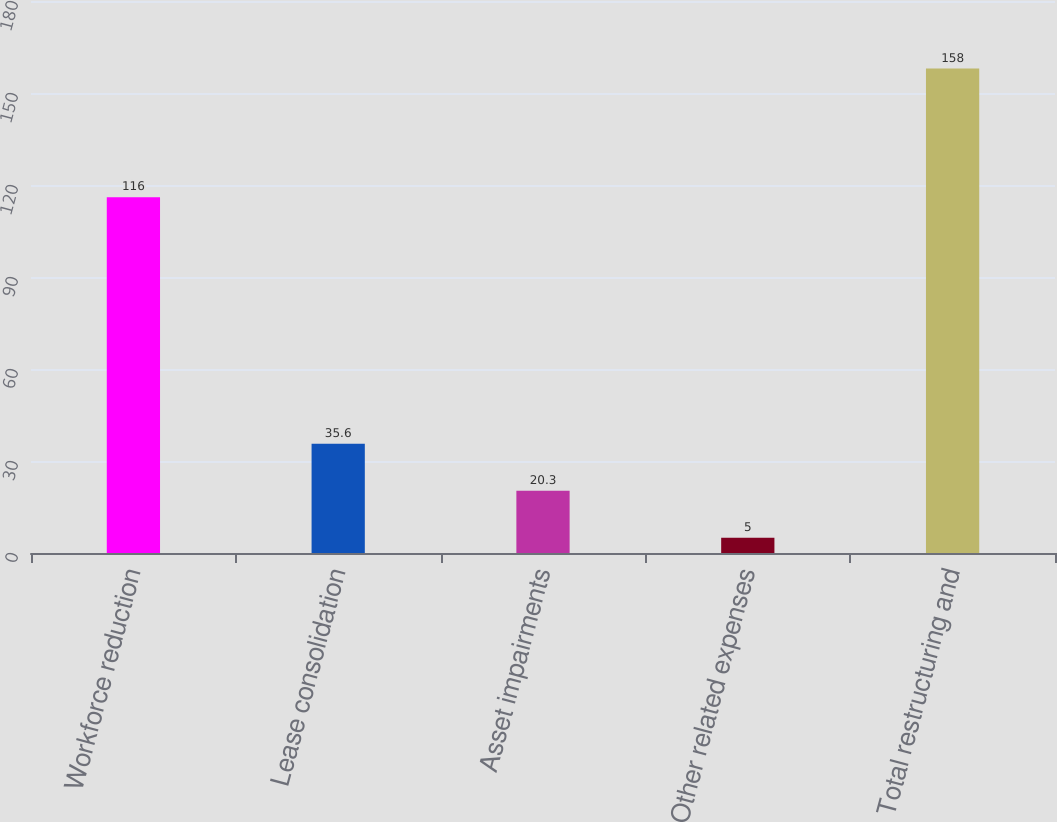Convert chart to OTSL. <chart><loc_0><loc_0><loc_500><loc_500><bar_chart><fcel>Workforce reduction<fcel>Lease consolidation<fcel>Asset impairments<fcel>Other related expenses<fcel>Total restructuring and<nl><fcel>116<fcel>35.6<fcel>20.3<fcel>5<fcel>158<nl></chart> 